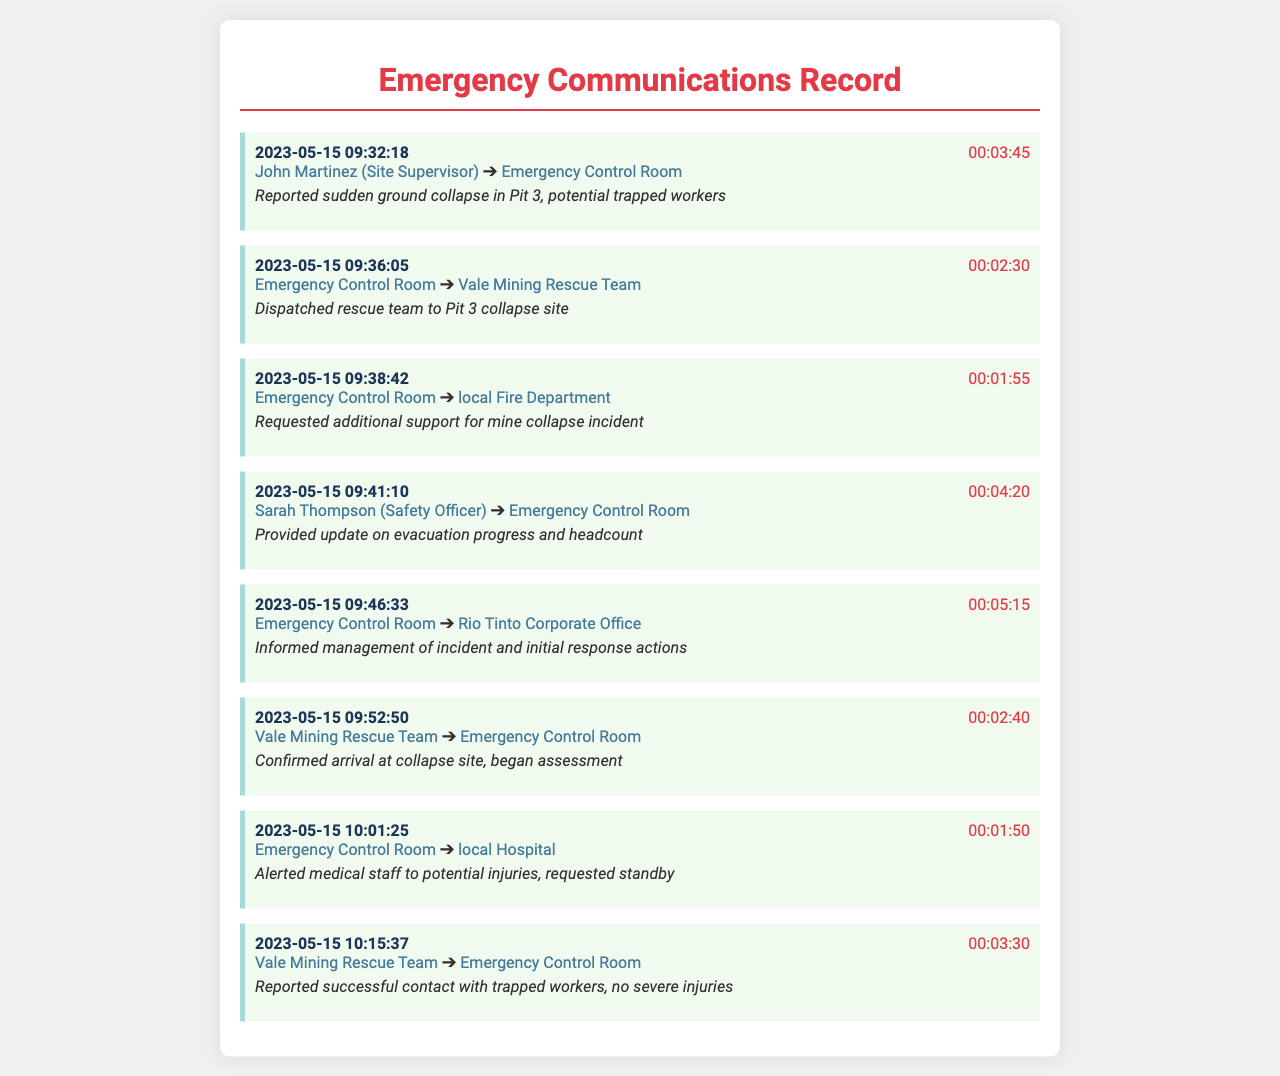What is the date of the first call? The date of the first call is at the top of the document and is marked as 2023-05-15.
Answer: 2023-05-15 Who reported the ground collapse? The caller of the first record is John Martinez, who is the Site Supervisor.
Answer: John Martinez What was the duration of the call to the Emergency Control Room regarding the evacuation? The call duration for Sarah Thompson's update is noted at 00:04:20.
Answer: 00:04:20 How many calls were made after the initial report of the collapse? After the first call, six more calls were recorded in the document, totaling seven calls.
Answer: 6 What did the Vale Mining Rescue Team confirm in their last call? In their last call, they confirmed successful contact with trapped workers and reported no severe injuries.
Answer: confirmed arrival at collapse site, began assessment Which organization was notified about the incident first? The report to the Emergency Control Room was the first communication made regarding the incident.
Answer: Emergency Control Room What was the total duration of the call made to local Hospital? The duration of the call made to the local Hospital is stated as 00:01:50.
Answer: 00:01:50 Who was alerted to standby for potential injuries? The local Hospital was alerted to standby for potential injuries.
Answer: local Hospital 